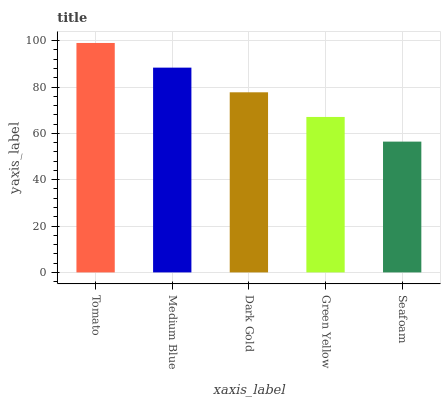Is Medium Blue the minimum?
Answer yes or no. No. Is Medium Blue the maximum?
Answer yes or no. No. Is Tomato greater than Medium Blue?
Answer yes or no. Yes. Is Medium Blue less than Tomato?
Answer yes or no. Yes. Is Medium Blue greater than Tomato?
Answer yes or no. No. Is Tomato less than Medium Blue?
Answer yes or no. No. Is Dark Gold the high median?
Answer yes or no. Yes. Is Dark Gold the low median?
Answer yes or no. Yes. Is Green Yellow the high median?
Answer yes or no. No. Is Tomato the low median?
Answer yes or no. No. 